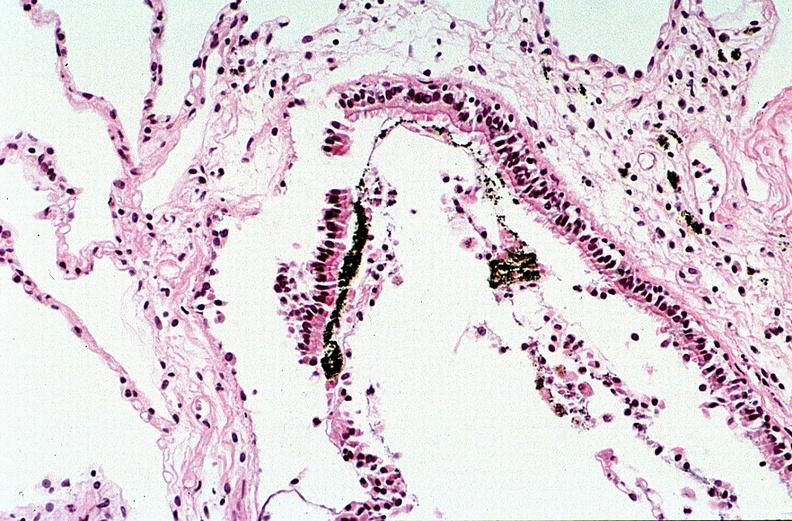does opened uterus and cervix with large cervical myoma protruding into vagina slide show thermal burn?
Answer the question using a single word or phrase. No 